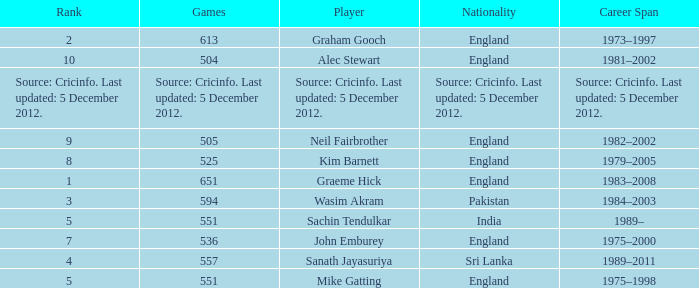What is the nationality of the player who played 505 games? England. 